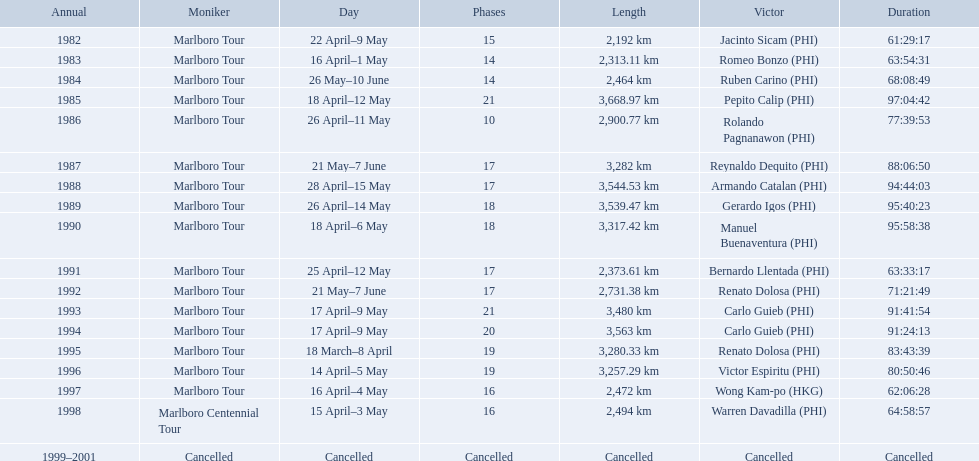What race did warren davadilla compete in in 1998? Marlboro Centennial Tour. How long did it take davadilla to complete the marlboro centennial tour? 64:58:57. Which year did warren davdilla (w.d.) appear? 1998. What tour did w.d. complete? Marlboro Centennial Tour. What is the time recorded in the same row as w.d.? 64:58:57. 